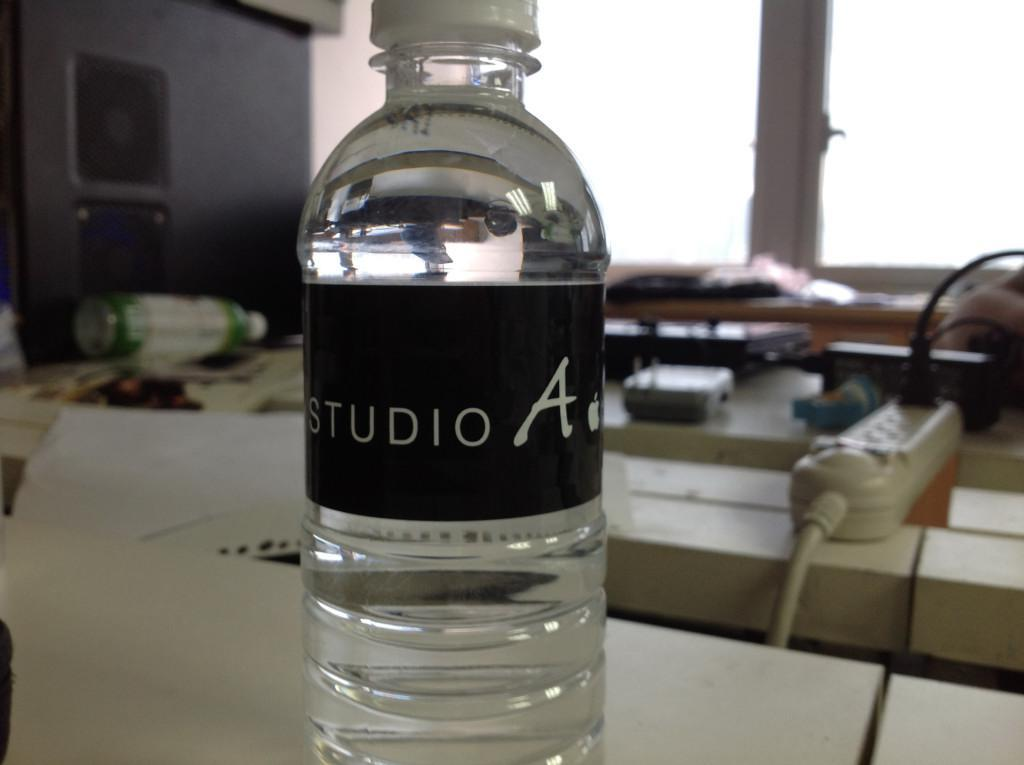<image>
Offer a succinct explanation of the picture presented. A bottle of Studio A water on a conference table. 